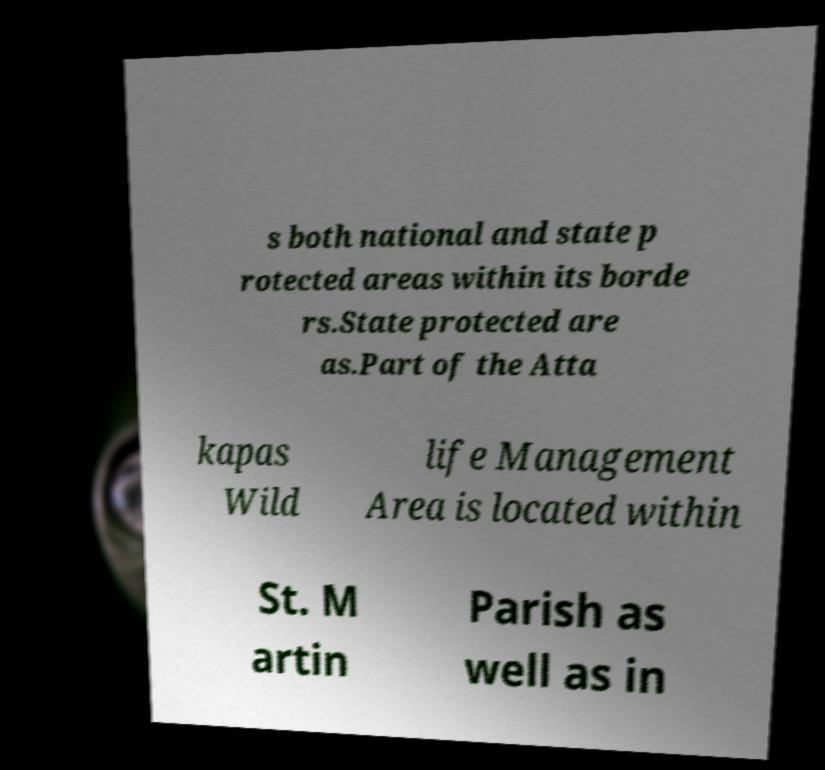Could you extract and type out the text from this image? s both national and state p rotected areas within its borde rs.State protected are as.Part of the Atta kapas Wild life Management Area is located within St. M artin Parish as well as in 